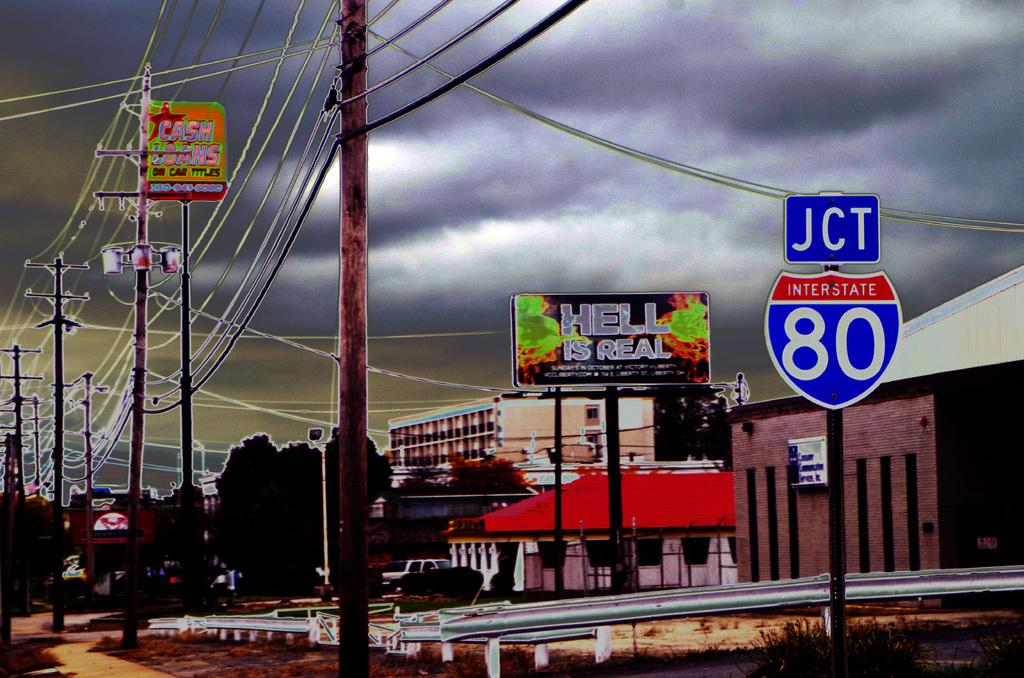<image>
Share a concise interpretation of the image provided. A street sign shows a junction for 80 